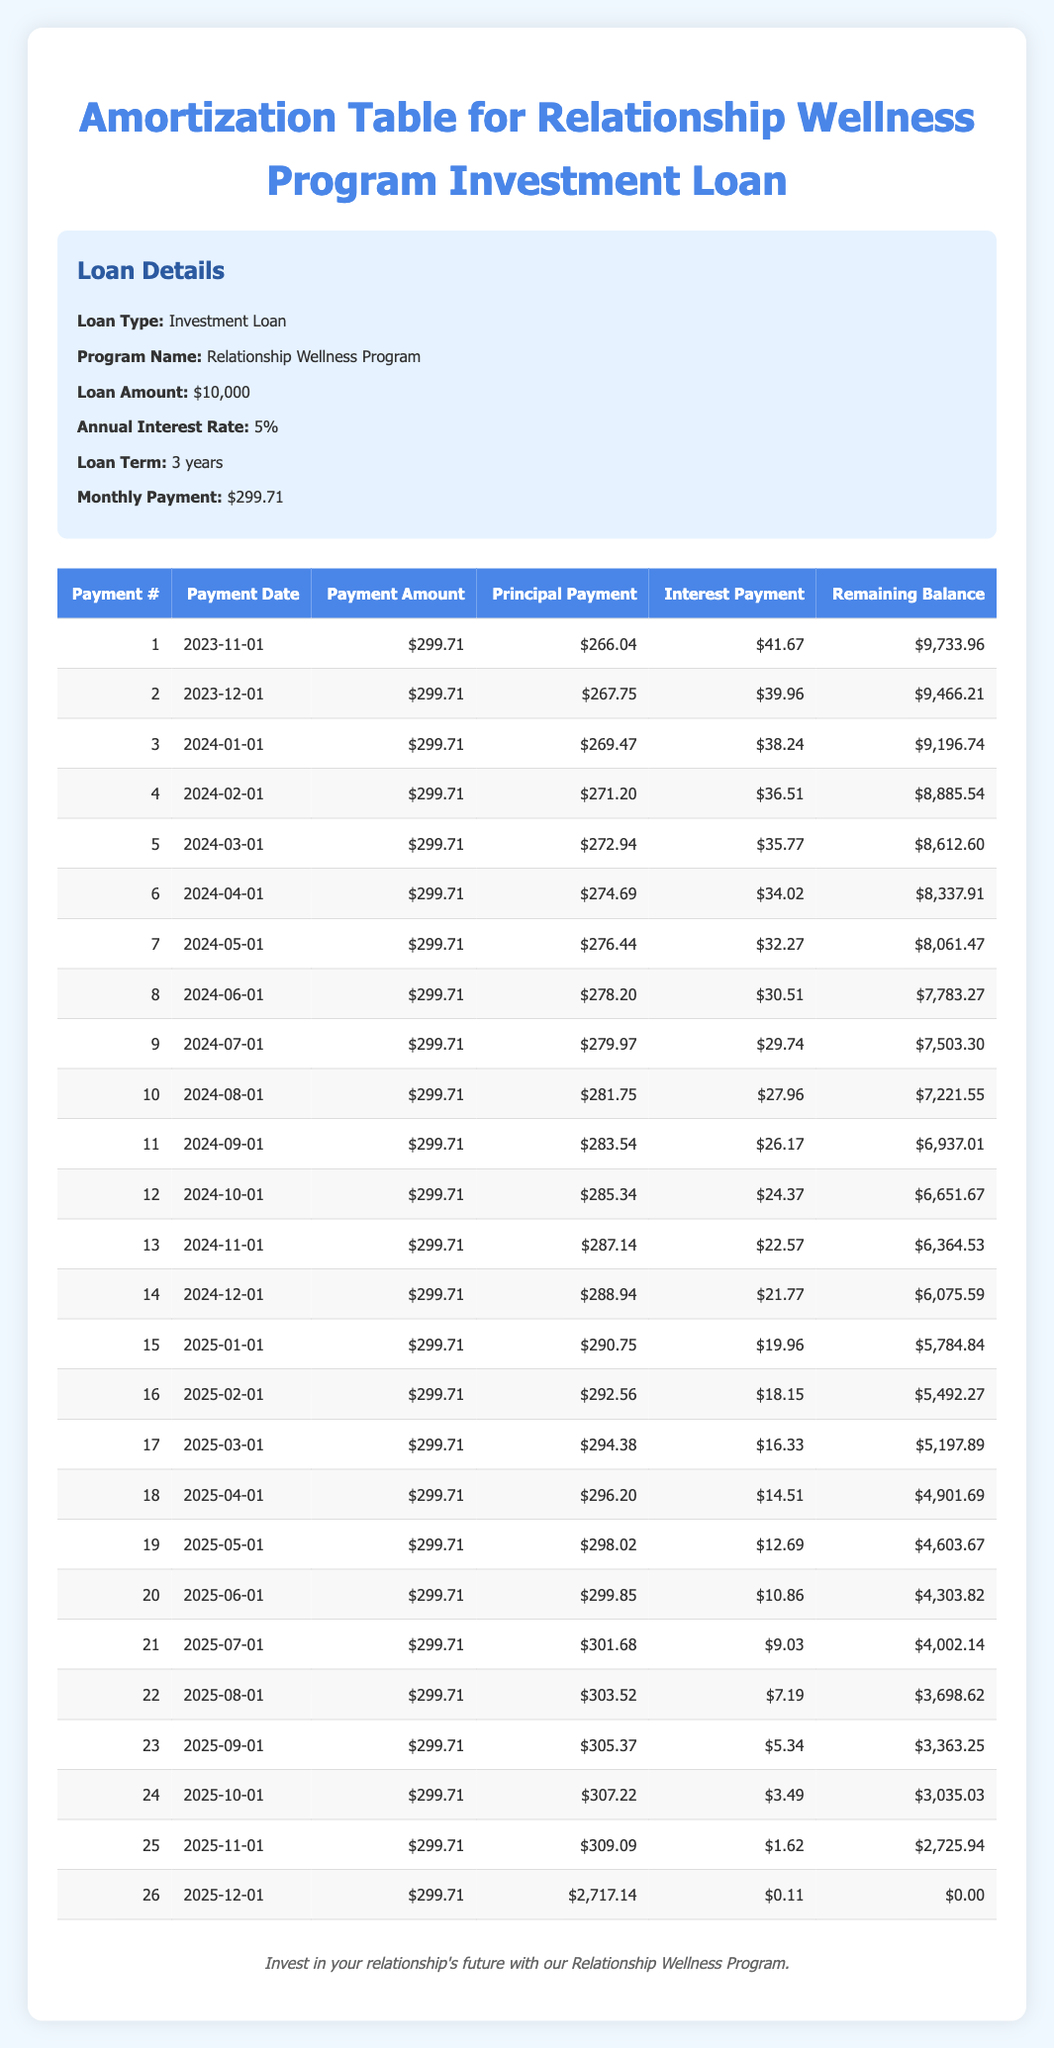What is the monthly payment amount for the loan? The table states that the monthly payment is $299.71.
Answer: $299.71 What is the total principal paid after the first three payments? To find the total principal after the first three payments, add the principal payments from the first three rows: 266.04 + 267.75 + 269.47 = 803.26.
Answer: $803.26 Is the interest payment for the first payment greater than the interest payment for the second payment? The interest payment for the first payment is 41.67, and for the second payment, it is 39.96. Since 41.67 is greater than 39.96, the statement is true.
Answer: Yes What is the remaining balance after the fourth payment? Looking at the fourth row, the remaining balance listed is 8885.54 after the fourth payment.
Answer: $8,885.54 What is the average principal payment made in the first six months? Add the principal payments from the first six months: 266.04 + 267.75 + 269.47 + 271.20 + 272.94 + 274.69 = 1,622.09. Divide by 6 to find the average: 1,622.09 / 6 = 270.35.
Answer: $270.35 What percentage of the first payment is used for interest? The first payment is $299.71 and the interest portion is 41.67. To find the percentage, calculate (41.67 / 299.71) * 100, which is approximately 13.9%.
Answer: 13.9% What is the remaining balance after the 12th payment? The table shows the remaining balance after the 12th payment is 6651.67.
Answer: $6,651.67 How much more principal is paid in the 25th payment compared to the 24th payment? The principal payment for the 25th payment is 309.09 and for the 24th payment, it is 307.22. The difference is 309.09 - 307.22 = 1.87.
Answer: $1.87 Is it true that the interest payment decreases each month? By reviewing the interest payment column in the table, it shows a consistent decrease from 41.67 to 0.11 across the payments, confirming that it decreases each month.
Answer: Yes 